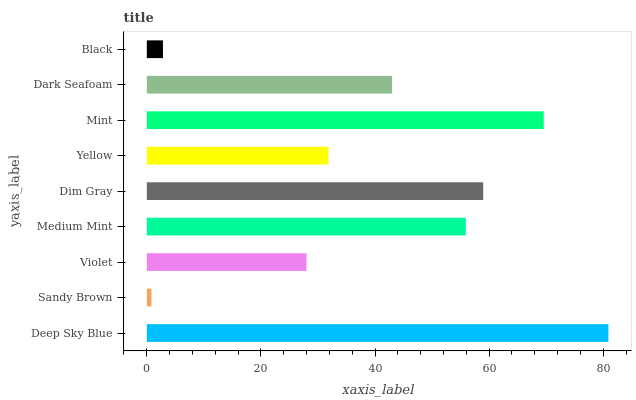Is Sandy Brown the minimum?
Answer yes or no. Yes. Is Deep Sky Blue the maximum?
Answer yes or no. Yes. Is Violet the minimum?
Answer yes or no. No. Is Violet the maximum?
Answer yes or no. No. Is Violet greater than Sandy Brown?
Answer yes or no. Yes. Is Sandy Brown less than Violet?
Answer yes or no. Yes. Is Sandy Brown greater than Violet?
Answer yes or no. No. Is Violet less than Sandy Brown?
Answer yes or no. No. Is Dark Seafoam the high median?
Answer yes or no. Yes. Is Dark Seafoam the low median?
Answer yes or no. Yes. Is Sandy Brown the high median?
Answer yes or no. No. Is Sandy Brown the low median?
Answer yes or no. No. 